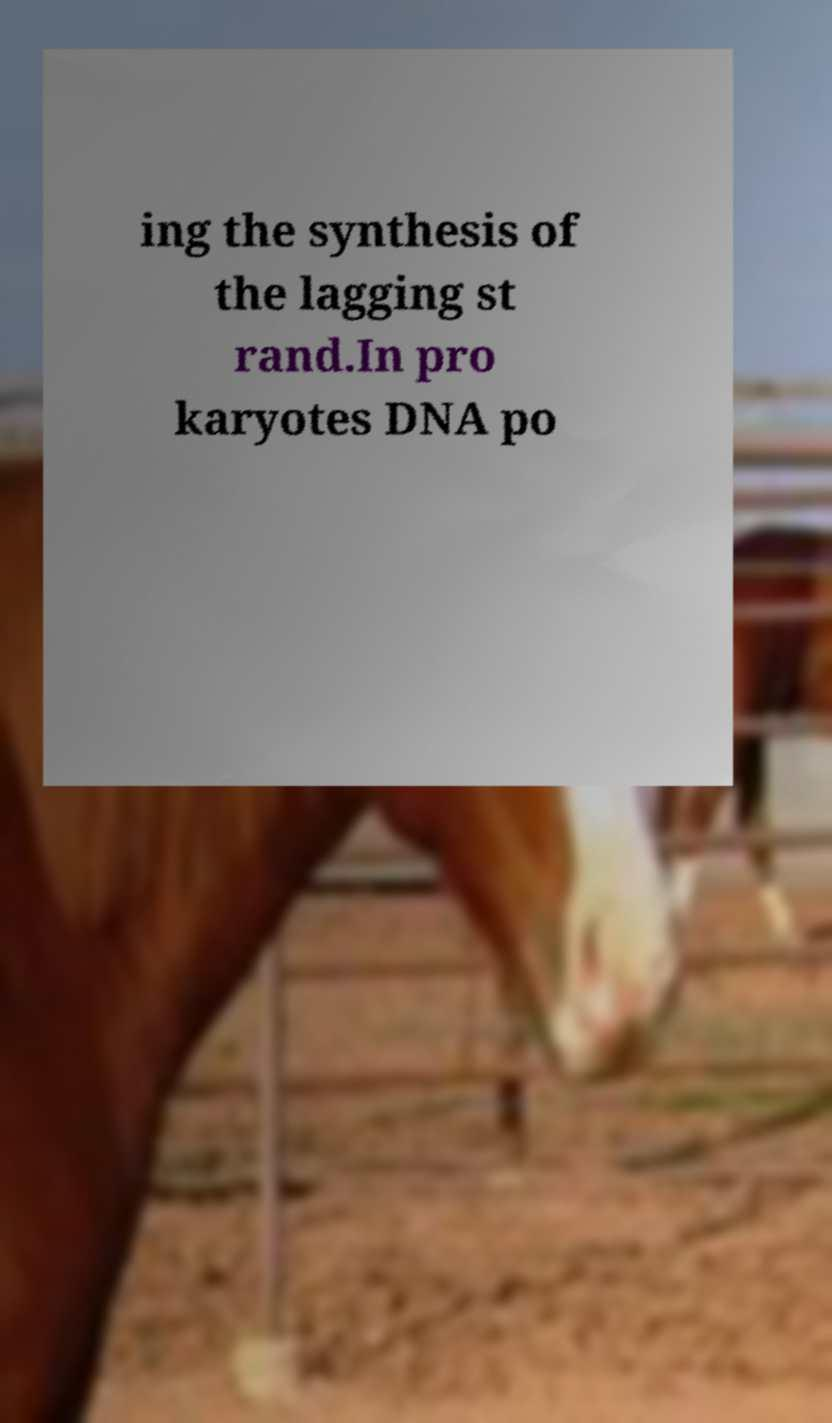What messages or text are displayed in this image? I need them in a readable, typed format. ing the synthesis of the lagging st rand.In pro karyotes DNA po 